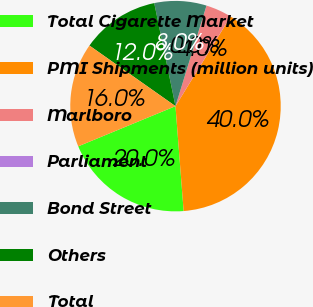<chart> <loc_0><loc_0><loc_500><loc_500><pie_chart><fcel>Total Cigarette Market<fcel>PMI Shipments (million units)<fcel>Marlboro<fcel>Parliament<fcel>Bond Street<fcel>Others<fcel>Total<nl><fcel>20.0%<fcel>39.99%<fcel>4.0%<fcel>0.01%<fcel>8.0%<fcel>12.0%<fcel>16.0%<nl></chart> 